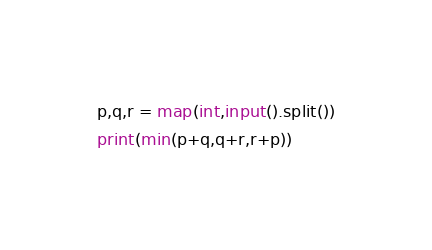<code> <loc_0><loc_0><loc_500><loc_500><_Python_>p,q,r = map(int,input().split())
print(min(p+q,q+r,r+p))</code> 